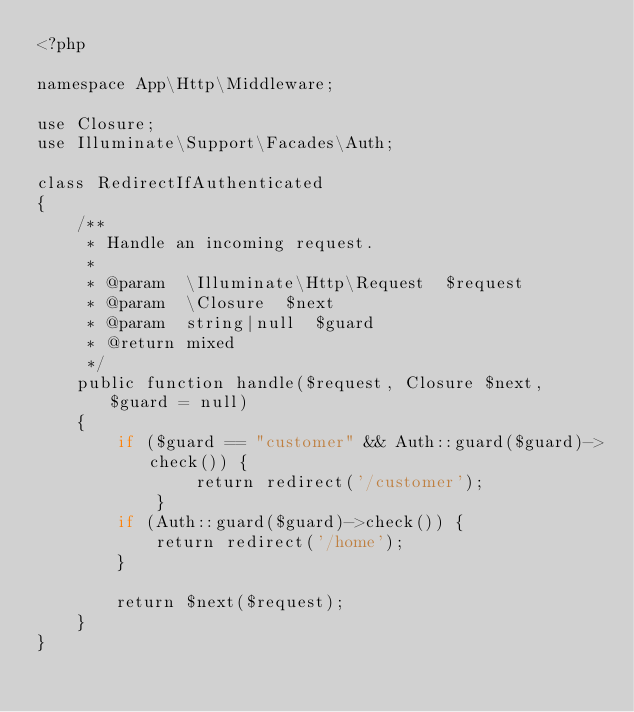<code> <loc_0><loc_0><loc_500><loc_500><_PHP_><?php

namespace App\Http\Middleware;

use Closure;
use Illuminate\Support\Facades\Auth;

class RedirectIfAuthenticated
{
    /**
     * Handle an incoming request.
     *
     * @param  \Illuminate\Http\Request  $request
     * @param  \Closure  $next
     * @param  string|null  $guard
     * @return mixed
     */
    public function handle($request, Closure $next, $guard = null)
    {
        if ($guard == "customer" && Auth::guard($guard)->check()) {
                return redirect('/customer');
            }
        if (Auth::guard($guard)->check()) {
            return redirect('/home');
        }

        return $next($request);
    }
}
</code> 